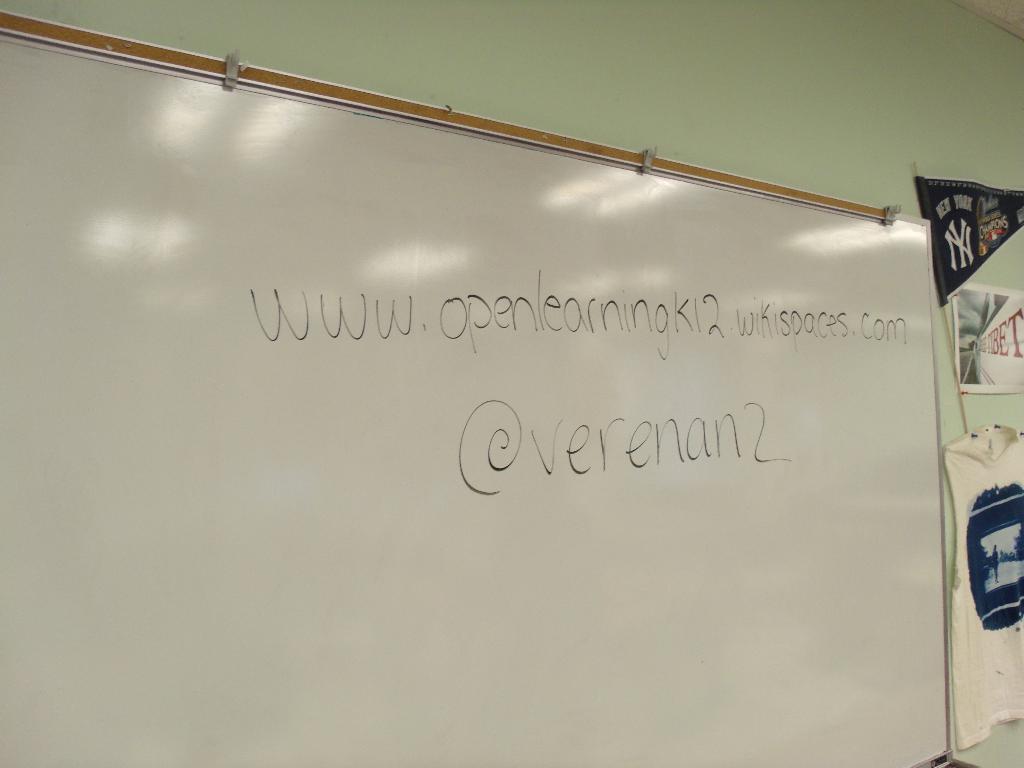What is the link on the whiteboard?
Ensure brevity in your answer.  Www.openlearningk12.wikispaces.com. 